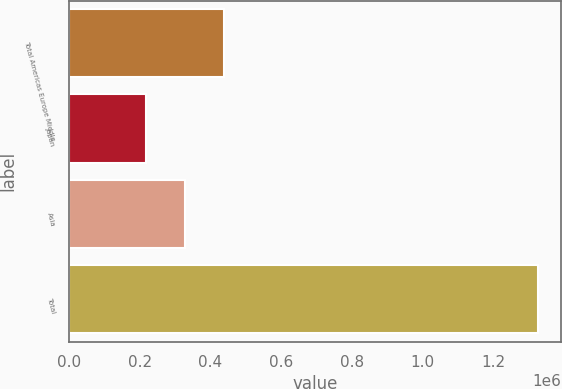<chart> <loc_0><loc_0><loc_500><loc_500><bar_chart><fcel>Total Americas Europe Middle<fcel>Japan<fcel>Asia<fcel>Total<nl><fcel>440270<fcel>218731<fcel>329500<fcel>1.32642e+06<nl></chart> 